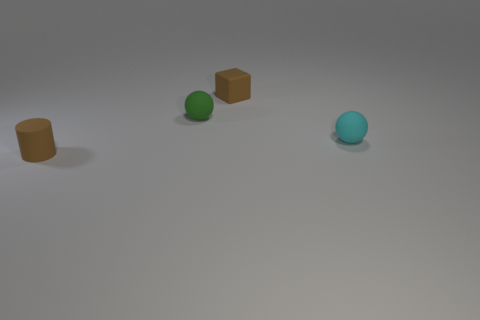What is the color of the matte object in front of the cyan thing that is behind the brown rubber object that is on the left side of the brown block?
Keep it short and to the point. Brown. There is a tiny matte sphere to the right of the small brown object right of the small brown matte cylinder; what number of tiny matte spheres are behind it?
Give a very brief answer. 1. How many brown matte things are in front of the tiny rubber ball that is behind the tiny cyan sphere?
Give a very brief answer. 1. There is a small brown rubber thing behind the rubber thing in front of the small cyan ball; are there any tiny brown rubber cubes left of it?
Offer a very short reply. No. What material is the small green thing that is the same shape as the cyan object?
Ensure brevity in your answer.  Rubber. What is the shape of the small brown matte object that is behind the rubber sphere in front of the green thing?
Your response must be concise. Cube. What number of small objects are purple matte things or cyan matte balls?
Offer a very short reply. 1. How many tiny brown objects are the same shape as the small cyan matte thing?
Your answer should be compact. 0. There is a cyan thing; does it have the same shape as the tiny green thing behind the cyan rubber ball?
Your response must be concise. Yes. How many tiny green rubber objects are behind the cyan rubber object?
Provide a succinct answer. 1. 